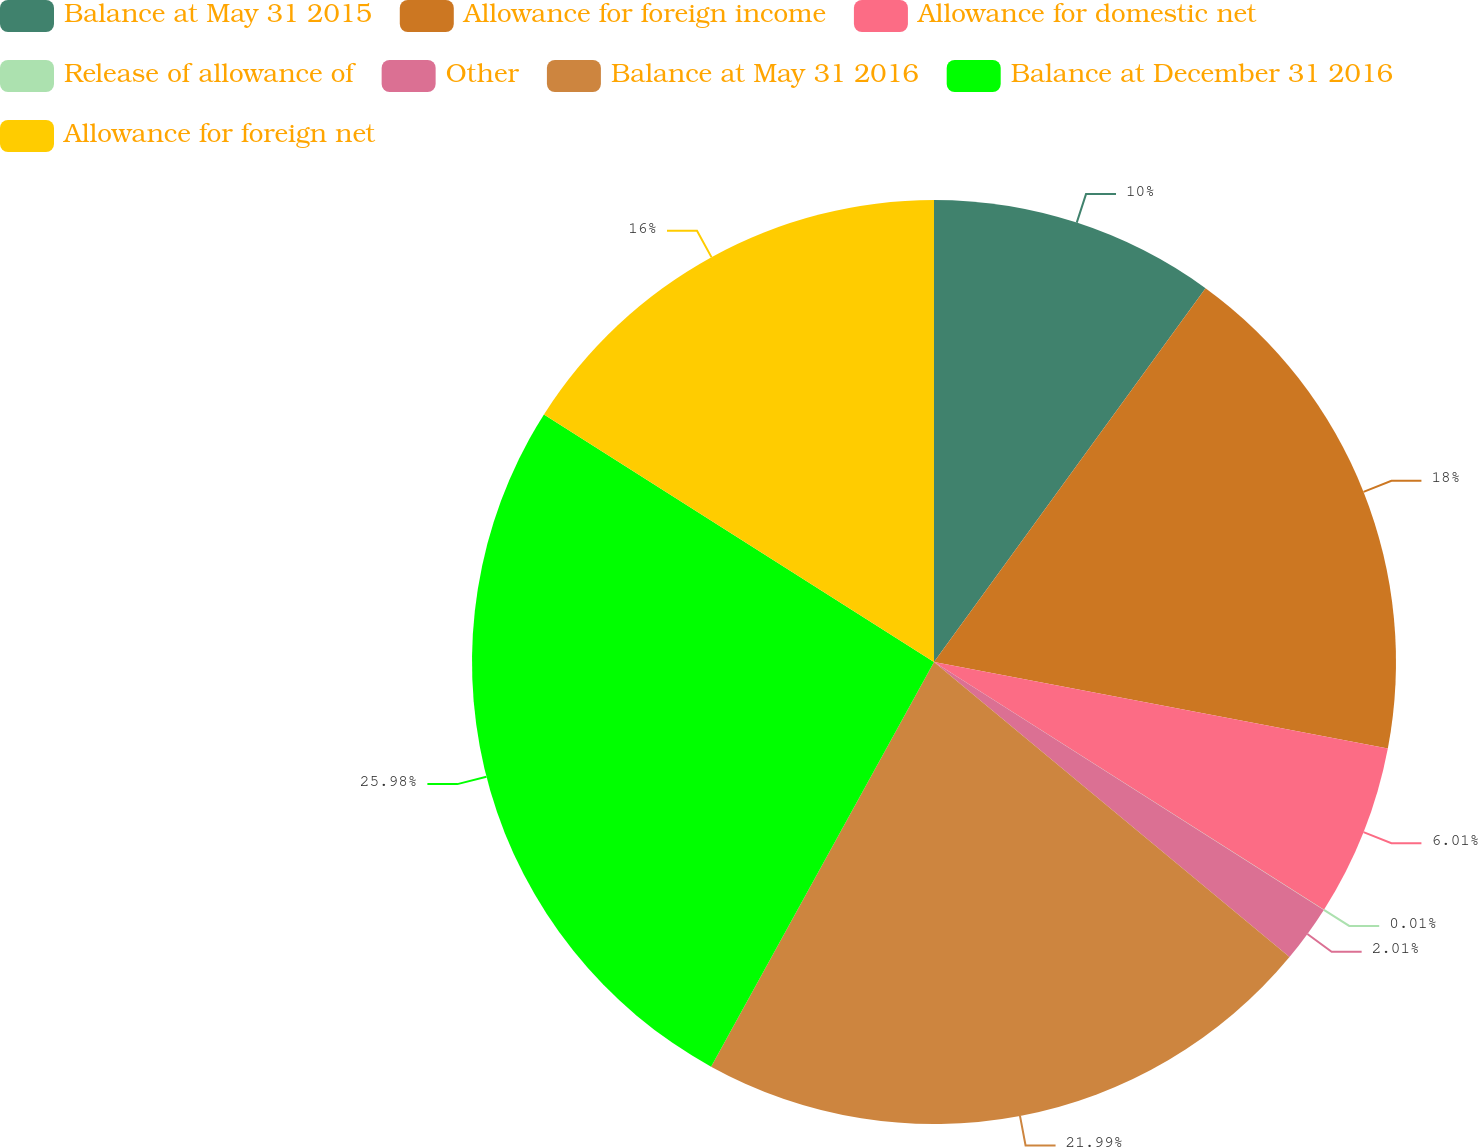Convert chart. <chart><loc_0><loc_0><loc_500><loc_500><pie_chart><fcel>Balance at May 31 2015<fcel>Allowance for foreign income<fcel>Allowance for domestic net<fcel>Release of allowance of<fcel>Other<fcel>Balance at May 31 2016<fcel>Balance at December 31 2016<fcel>Allowance for foreign net<nl><fcel>10.0%<fcel>18.0%<fcel>6.01%<fcel>0.01%<fcel>2.01%<fcel>21.99%<fcel>25.99%<fcel>16.0%<nl></chart> 